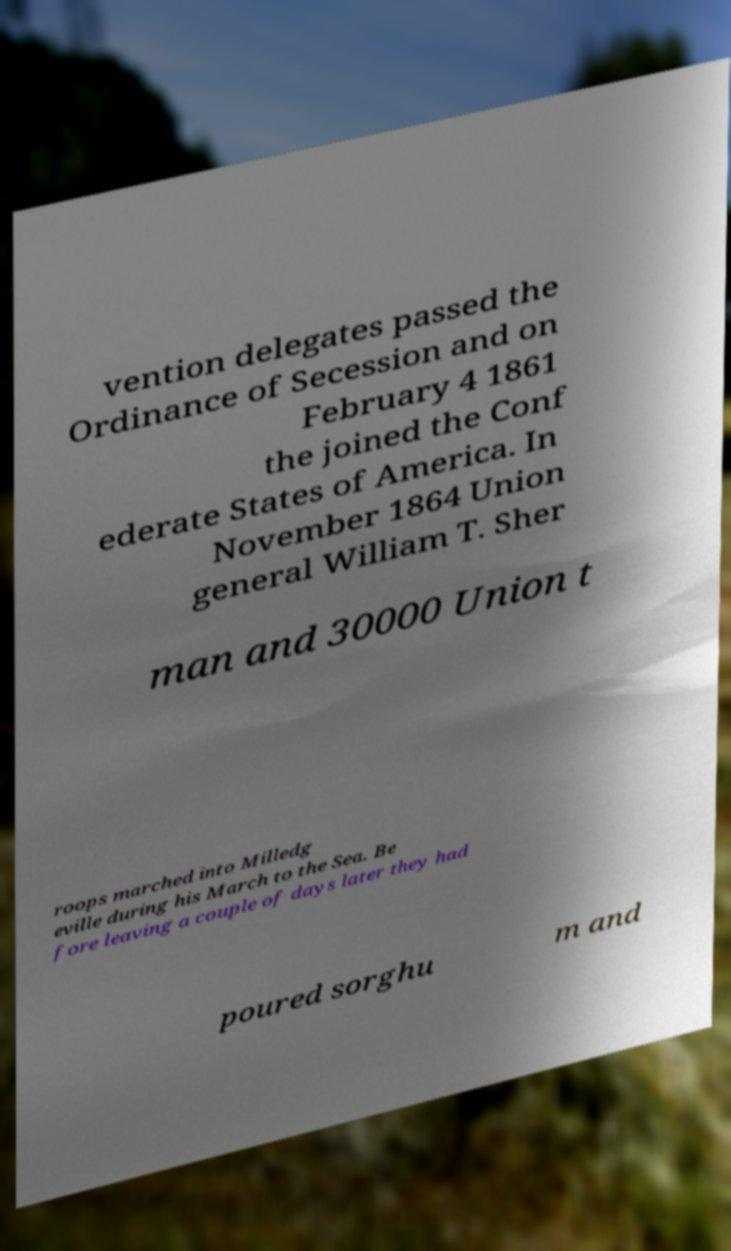Can you read and provide the text displayed in the image?This photo seems to have some interesting text. Can you extract and type it out for me? vention delegates passed the Ordinance of Secession and on February 4 1861 the joined the Conf ederate States of America. In November 1864 Union general William T. Sher man and 30000 Union t roops marched into Milledg eville during his March to the Sea. Be fore leaving a couple of days later they had poured sorghu m and 